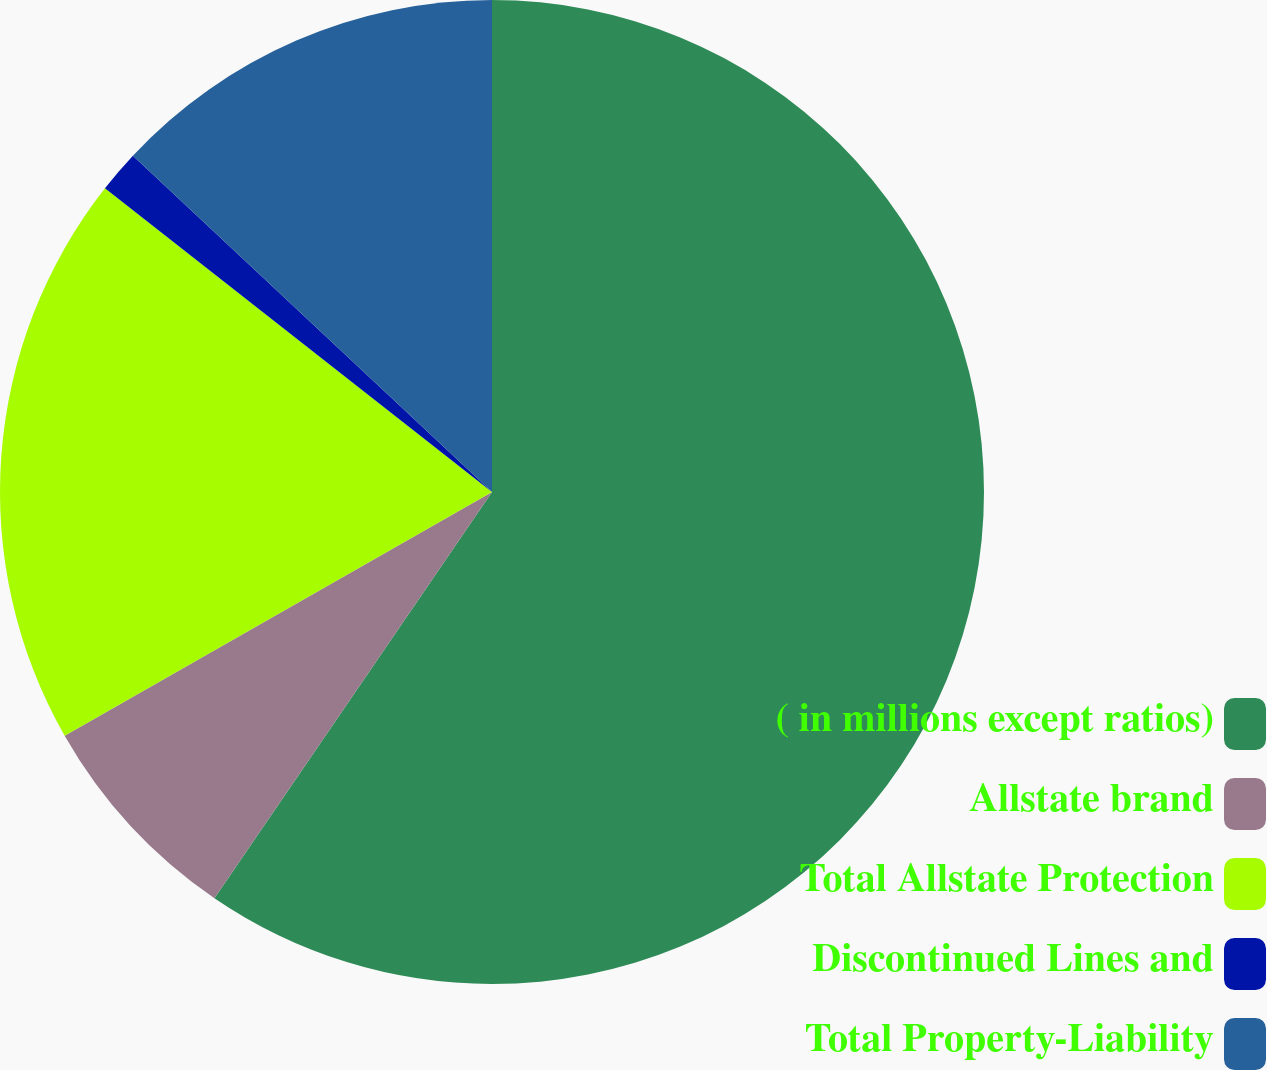Convert chart. <chart><loc_0><loc_0><loc_500><loc_500><pie_chart><fcel>( in millions except ratios)<fcel>Allstate brand<fcel>Total Allstate Protection<fcel>Discontinued Lines and<fcel>Total Property-Liability<nl><fcel>59.54%<fcel>7.21%<fcel>18.84%<fcel>1.39%<fcel>13.02%<nl></chart> 